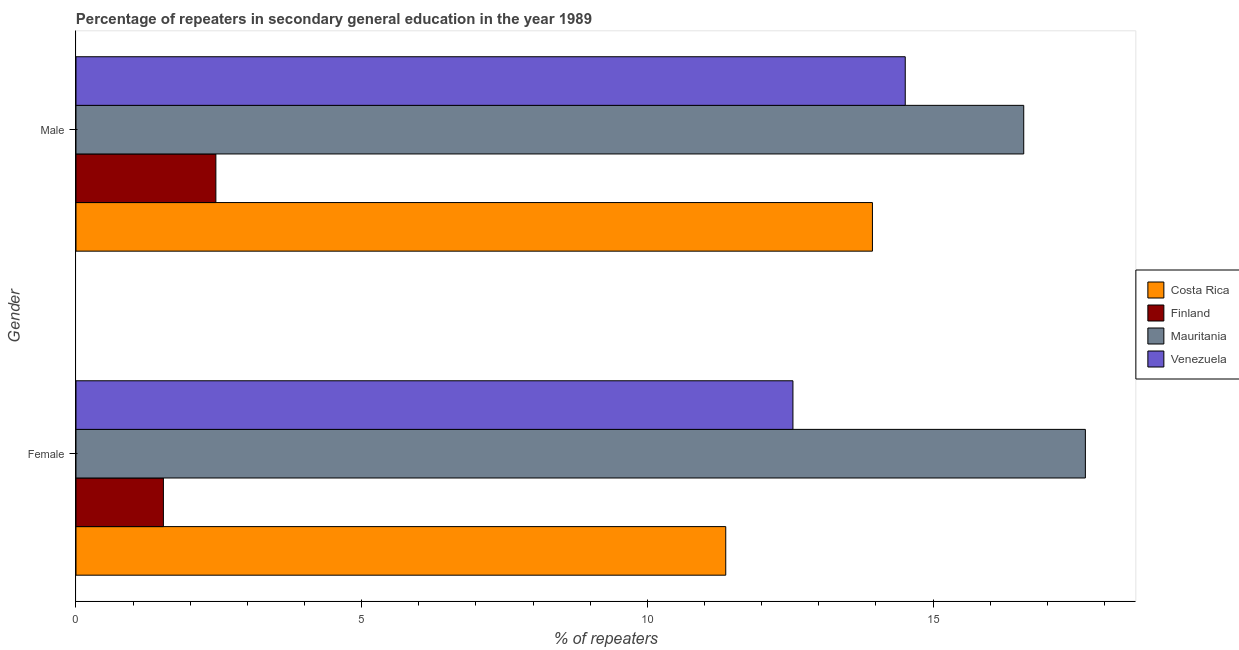How many different coloured bars are there?
Give a very brief answer. 4. How many groups of bars are there?
Your answer should be very brief. 2. How many bars are there on the 1st tick from the top?
Provide a succinct answer. 4. What is the percentage of male repeaters in Finland?
Your response must be concise. 2.45. Across all countries, what is the maximum percentage of female repeaters?
Provide a short and direct response. 17.67. Across all countries, what is the minimum percentage of male repeaters?
Keep it short and to the point. 2.45. In which country was the percentage of male repeaters maximum?
Offer a very short reply. Mauritania. What is the total percentage of female repeaters in the graph?
Make the answer very short. 43.12. What is the difference between the percentage of male repeaters in Costa Rica and that in Venezuela?
Your answer should be compact. -0.57. What is the difference between the percentage of male repeaters in Mauritania and the percentage of female repeaters in Finland?
Offer a very short reply. 15.06. What is the average percentage of male repeaters per country?
Your answer should be very brief. 11.87. What is the difference between the percentage of female repeaters and percentage of male repeaters in Finland?
Make the answer very short. -0.92. What is the ratio of the percentage of male repeaters in Finland to that in Costa Rica?
Provide a short and direct response. 0.18. Is the percentage of male repeaters in Venezuela less than that in Costa Rica?
Ensure brevity in your answer.  No. In how many countries, is the percentage of male repeaters greater than the average percentage of male repeaters taken over all countries?
Give a very brief answer. 3. Does the graph contain any zero values?
Your answer should be very brief. No. Where does the legend appear in the graph?
Make the answer very short. Center right. What is the title of the graph?
Offer a very short reply. Percentage of repeaters in secondary general education in the year 1989. What is the label or title of the X-axis?
Your answer should be compact. % of repeaters. What is the label or title of the Y-axis?
Your answer should be compact. Gender. What is the % of repeaters in Costa Rica in Female?
Your answer should be very brief. 11.37. What is the % of repeaters of Finland in Female?
Provide a succinct answer. 1.53. What is the % of repeaters of Mauritania in Female?
Give a very brief answer. 17.67. What is the % of repeaters in Venezuela in Female?
Provide a succinct answer. 12.55. What is the % of repeaters in Costa Rica in Male?
Provide a short and direct response. 13.94. What is the % of repeaters in Finland in Male?
Give a very brief answer. 2.45. What is the % of repeaters in Mauritania in Male?
Make the answer very short. 16.59. What is the % of repeaters of Venezuela in Male?
Keep it short and to the point. 14.51. Across all Gender, what is the maximum % of repeaters of Costa Rica?
Offer a very short reply. 13.94. Across all Gender, what is the maximum % of repeaters in Finland?
Keep it short and to the point. 2.45. Across all Gender, what is the maximum % of repeaters of Mauritania?
Your answer should be compact. 17.67. Across all Gender, what is the maximum % of repeaters of Venezuela?
Offer a very short reply. 14.51. Across all Gender, what is the minimum % of repeaters of Costa Rica?
Offer a terse response. 11.37. Across all Gender, what is the minimum % of repeaters in Finland?
Keep it short and to the point. 1.53. Across all Gender, what is the minimum % of repeaters in Mauritania?
Offer a terse response. 16.59. Across all Gender, what is the minimum % of repeaters of Venezuela?
Your answer should be very brief. 12.55. What is the total % of repeaters in Costa Rica in the graph?
Make the answer very short. 25.31. What is the total % of repeaters of Finland in the graph?
Offer a terse response. 3.98. What is the total % of repeaters in Mauritania in the graph?
Ensure brevity in your answer.  34.25. What is the total % of repeaters in Venezuela in the graph?
Your answer should be very brief. 27.06. What is the difference between the % of repeaters of Costa Rica in Female and that in Male?
Your answer should be very brief. -2.57. What is the difference between the % of repeaters of Finland in Female and that in Male?
Provide a short and direct response. -0.92. What is the difference between the % of repeaters of Mauritania in Female and that in Male?
Your answer should be very brief. 1.08. What is the difference between the % of repeaters in Venezuela in Female and that in Male?
Provide a succinct answer. -1.97. What is the difference between the % of repeaters in Costa Rica in Female and the % of repeaters in Finland in Male?
Provide a short and direct response. 8.92. What is the difference between the % of repeaters in Costa Rica in Female and the % of repeaters in Mauritania in Male?
Provide a short and direct response. -5.22. What is the difference between the % of repeaters of Costa Rica in Female and the % of repeaters of Venezuela in Male?
Your response must be concise. -3.14. What is the difference between the % of repeaters in Finland in Female and the % of repeaters in Mauritania in Male?
Your answer should be compact. -15.06. What is the difference between the % of repeaters in Finland in Female and the % of repeaters in Venezuela in Male?
Your answer should be compact. -12.98. What is the difference between the % of repeaters in Mauritania in Female and the % of repeaters in Venezuela in Male?
Make the answer very short. 3.15. What is the average % of repeaters in Costa Rica per Gender?
Provide a short and direct response. 12.66. What is the average % of repeaters in Finland per Gender?
Keep it short and to the point. 1.99. What is the average % of repeaters of Mauritania per Gender?
Offer a very short reply. 17.13. What is the average % of repeaters of Venezuela per Gender?
Give a very brief answer. 13.53. What is the difference between the % of repeaters of Costa Rica and % of repeaters of Finland in Female?
Give a very brief answer. 9.84. What is the difference between the % of repeaters in Costa Rica and % of repeaters in Mauritania in Female?
Ensure brevity in your answer.  -6.29. What is the difference between the % of repeaters in Costa Rica and % of repeaters in Venezuela in Female?
Your response must be concise. -1.18. What is the difference between the % of repeaters of Finland and % of repeaters of Mauritania in Female?
Your response must be concise. -16.14. What is the difference between the % of repeaters in Finland and % of repeaters in Venezuela in Female?
Keep it short and to the point. -11.02. What is the difference between the % of repeaters in Mauritania and % of repeaters in Venezuela in Female?
Provide a short and direct response. 5.12. What is the difference between the % of repeaters in Costa Rica and % of repeaters in Finland in Male?
Provide a short and direct response. 11.49. What is the difference between the % of repeaters in Costa Rica and % of repeaters in Mauritania in Male?
Provide a succinct answer. -2.65. What is the difference between the % of repeaters in Costa Rica and % of repeaters in Venezuela in Male?
Your answer should be very brief. -0.57. What is the difference between the % of repeaters of Finland and % of repeaters of Mauritania in Male?
Your answer should be very brief. -14.14. What is the difference between the % of repeaters of Finland and % of repeaters of Venezuela in Male?
Provide a succinct answer. -12.07. What is the difference between the % of repeaters in Mauritania and % of repeaters in Venezuela in Male?
Make the answer very short. 2.07. What is the ratio of the % of repeaters of Costa Rica in Female to that in Male?
Provide a short and direct response. 0.82. What is the ratio of the % of repeaters in Finland in Female to that in Male?
Give a very brief answer. 0.62. What is the ratio of the % of repeaters in Mauritania in Female to that in Male?
Offer a terse response. 1.07. What is the ratio of the % of repeaters in Venezuela in Female to that in Male?
Give a very brief answer. 0.86. What is the difference between the highest and the second highest % of repeaters in Costa Rica?
Provide a succinct answer. 2.57. What is the difference between the highest and the second highest % of repeaters of Finland?
Offer a very short reply. 0.92. What is the difference between the highest and the second highest % of repeaters of Mauritania?
Provide a succinct answer. 1.08. What is the difference between the highest and the second highest % of repeaters of Venezuela?
Ensure brevity in your answer.  1.97. What is the difference between the highest and the lowest % of repeaters of Costa Rica?
Make the answer very short. 2.57. What is the difference between the highest and the lowest % of repeaters of Finland?
Offer a terse response. 0.92. What is the difference between the highest and the lowest % of repeaters in Mauritania?
Give a very brief answer. 1.08. What is the difference between the highest and the lowest % of repeaters in Venezuela?
Ensure brevity in your answer.  1.97. 